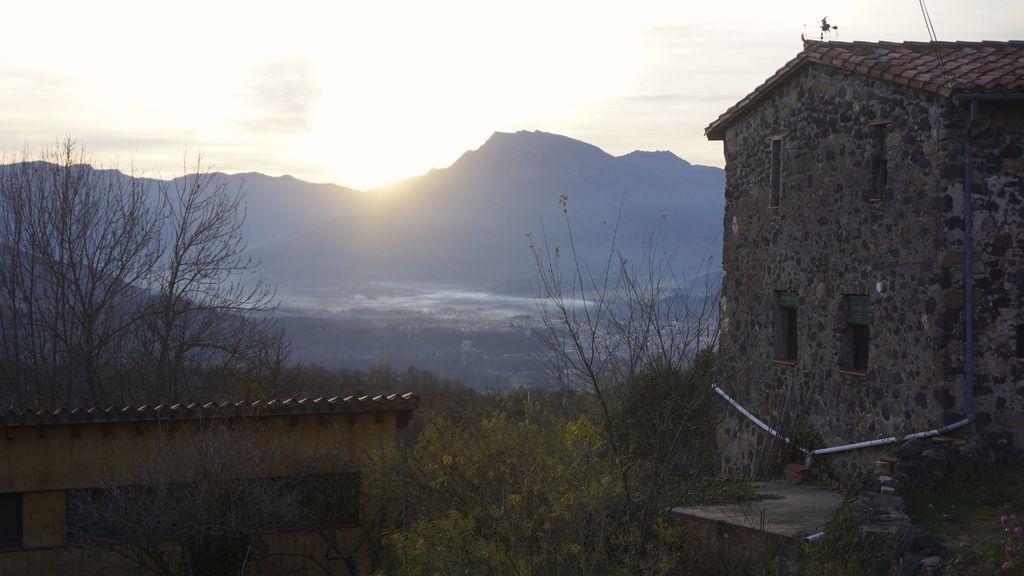Can you describe this image briefly? In this picture there is a house on the right side of the image and there is a shed at the bottom side of the image, there is greenery in the image, there is water and mountains in the background area of the image. 